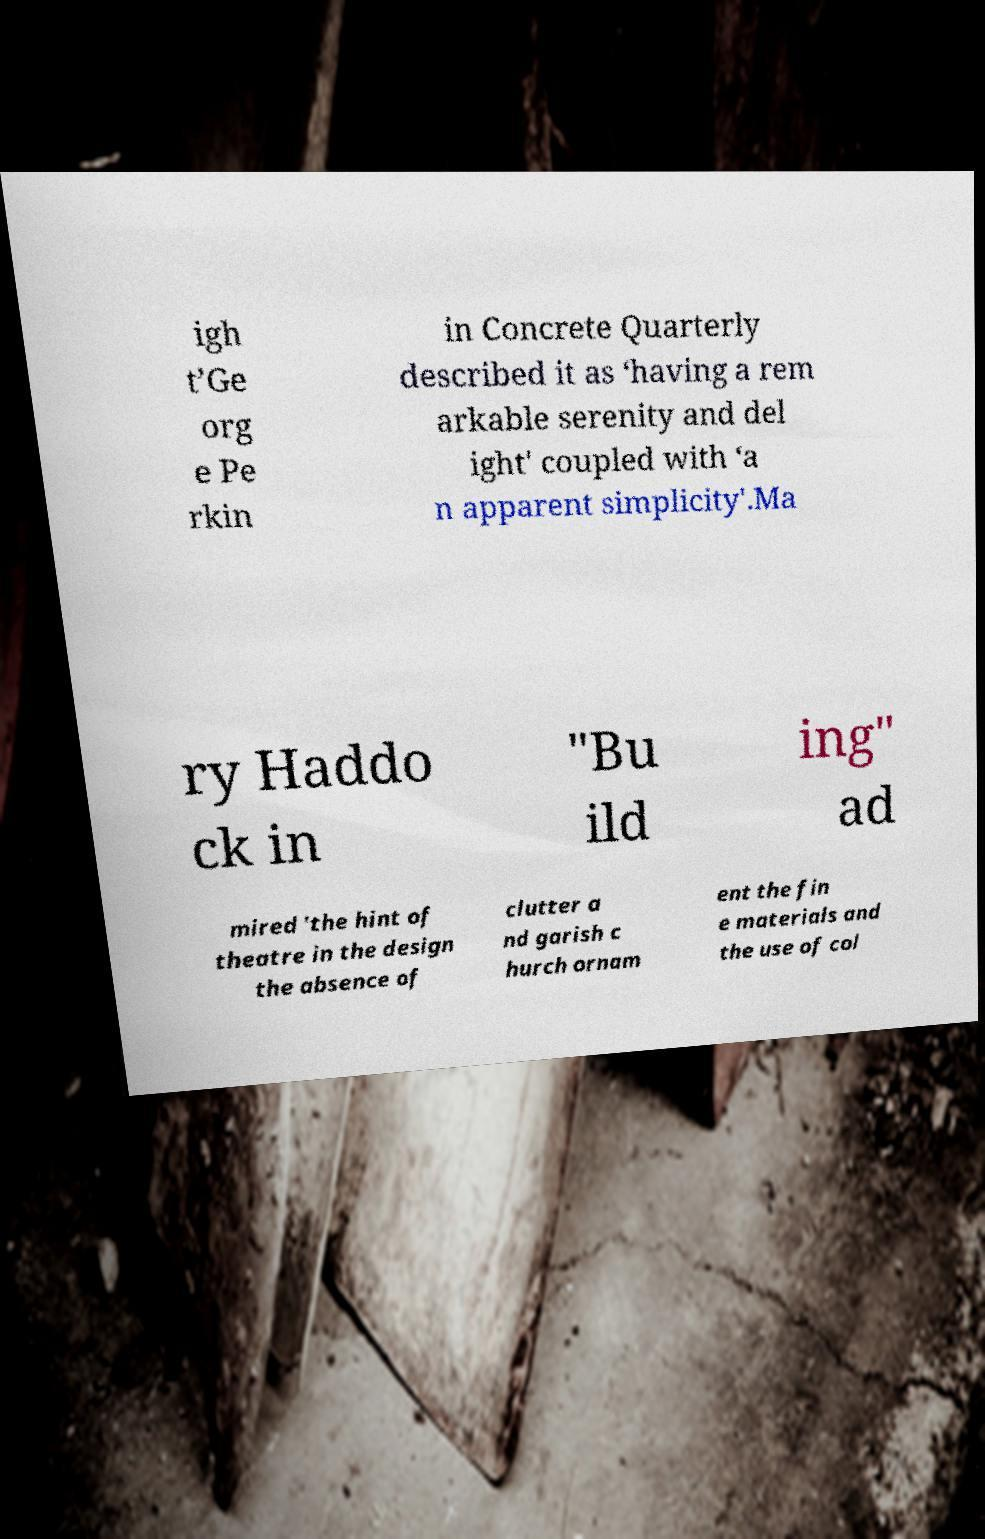I need the written content from this picture converted into text. Can you do that? igh t’Ge org e Pe rkin in Concrete Quarterly described it as ‘having a rem arkable serenity and del ight' coupled with ‘a n apparent simplicity'.Ma ry Haddo ck in "Bu ild ing" ad mired 'the hint of theatre in the design the absence of clutter a nd garish c hurch ornam ent the fin e materials and the use of col 